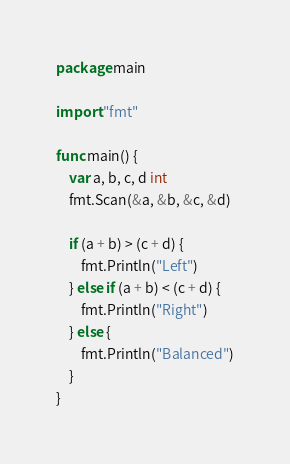<code> <loc_0><loc_0><loc_500><loc_500><_Go_>package main

import "fmt"

func main() {
	var a, b, c, d int
	fmt.Scan(&a, &b, &c, &d)

	if (a + b) > (c + d) {
		fmt.Println("Left")
	} else if (a + b) < (c + d) {
		fmt.Println("Right")
	} else {
		fmt.Println("Balanced")
	}
}
</code> 